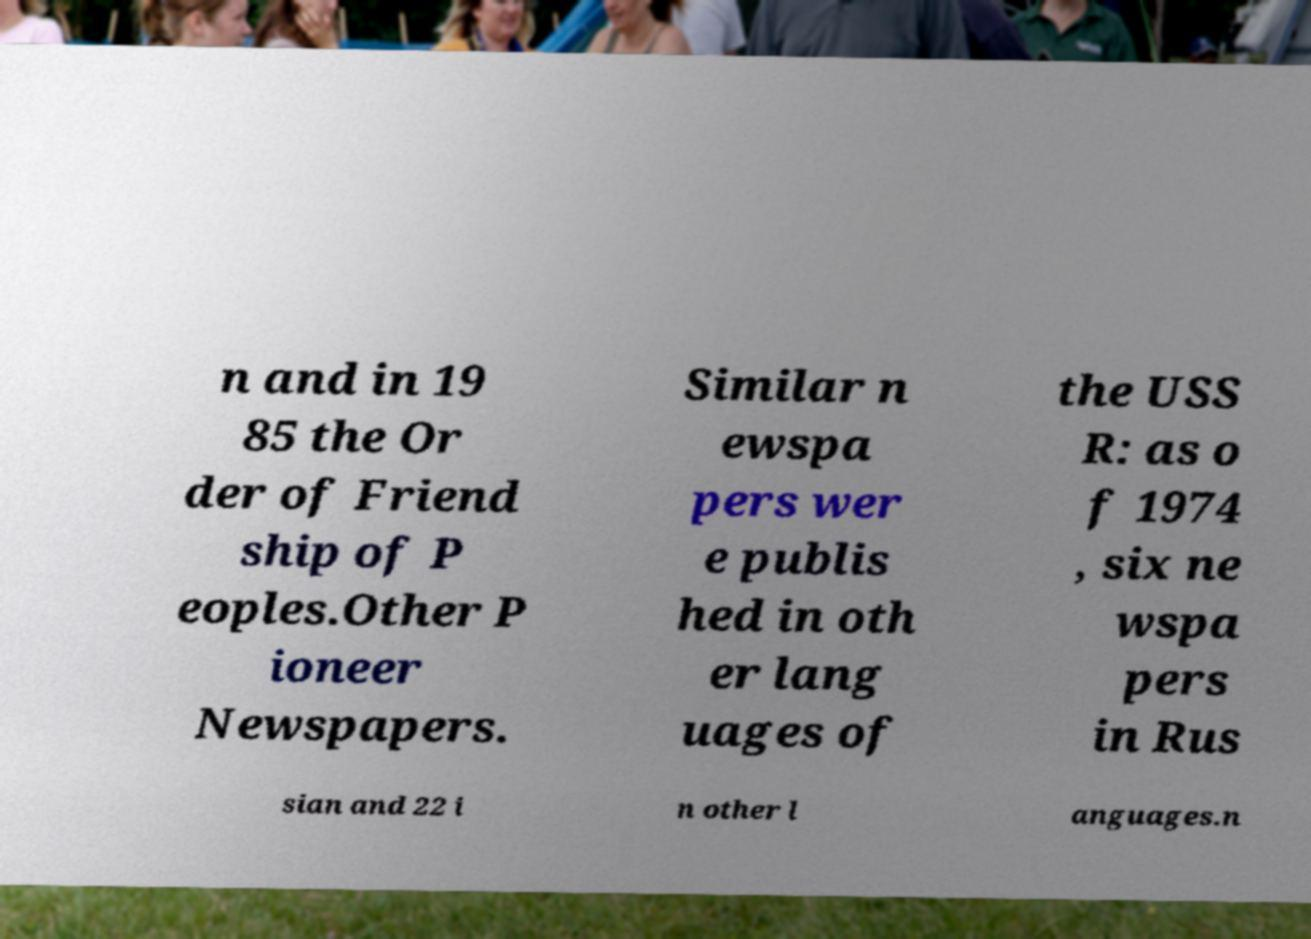Please read and relay the text visible in this image. What does it say? n and in 19 85 the Or der of Friend ship of P eoples.Other P ioneer Newspapers. Similar n ewspa pers wer e publis hed in oth er lang uages of the USS R: as o f 1974 , six ne wspa pers in Rus sian and 22 i n other l anguages.n 